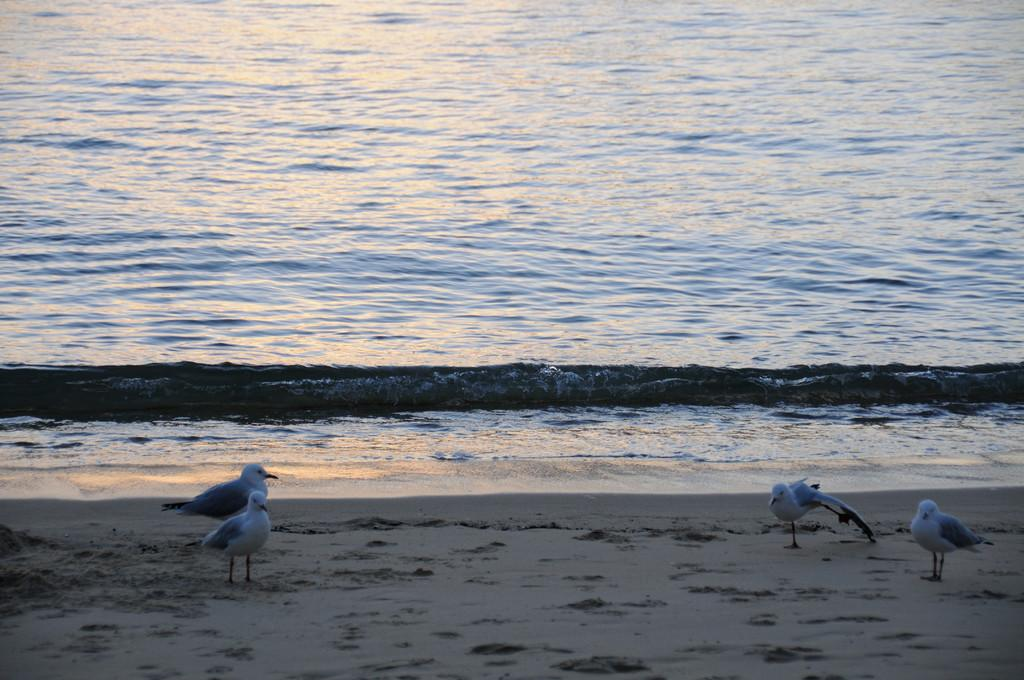How many birds are present in the image? There are four birds in the image. Where are the birds located in the image? The birds are standing on the beach. What natural feature can be seen behind the birds? The ocean is visible behind the birds. What type of question is being asked by one of the birds in the image? There is no indication in the image that any of the birds are asking a question. 